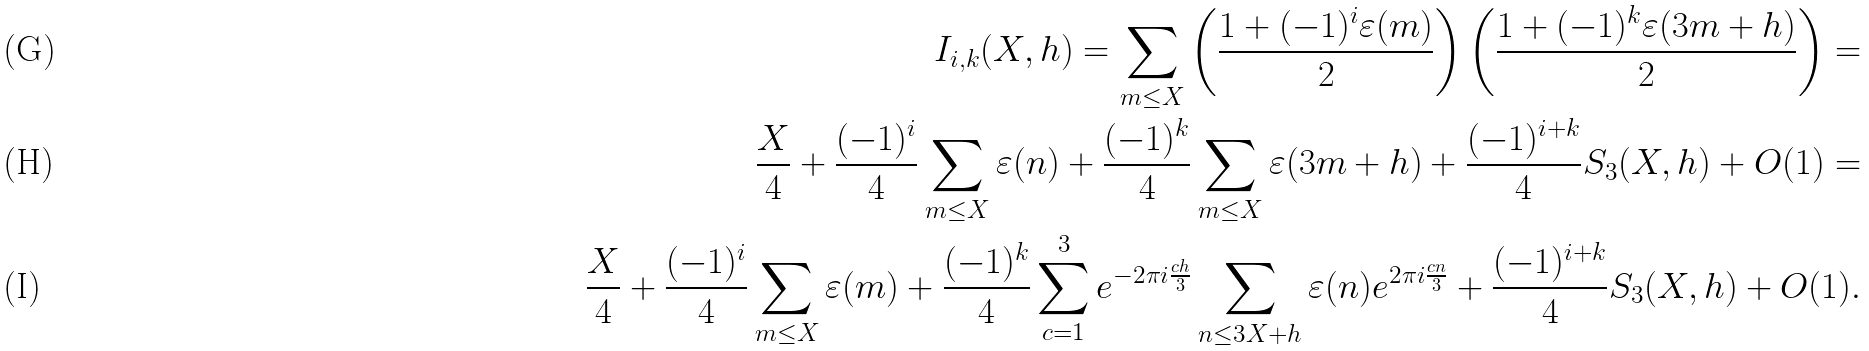Convert formula to latex. <formula><loc_0><loc_0><loc_500><loc_500>I _ { i , k } ( X , h ) = \sum _ { m \leq X } \left ( \frac { 1 + ( - 1 ) ^ { i } \varepsilon ( m ) } { 2 } \right ) \left ( \frac { 1 + ( - 1 ) ^ { k } \varepsilon ( 3 m + h ) } { 2 } \right ) = \\ \frac { X } { 4 } + \frac { ( - 1 ) ^ { i } } { 4 } \sum _ { m \leq X } \varepsilon ( n ) + \frac { ( - 1 ) ^ { k } } { 4 } \sum _ { m \leq X } \varepsilon ( 3 m + h ) + \frac { ( - 1 ) ^ { i + k } } { 4 } S _ { 3 } ( X , h ) + O ( 1 ) = \\ \frac { X } { 4 } + \frac { ( - 1 ) ^ { i } } { 4 } \sum _ { m \leq X } \varepsilon ( m ) + \frac { ( - 1 ) ^ { k } } { 4 } \sum _ { c = 1 } ^ { 3 } e ^ { - 2 \pi i \frac { c h } { 3 } } \sum _ { n \leq 3 X + h } \varepsilon ( n ) e ^ { 2 \pi i \frac { c n } { 3 } } + \frac { ( - 1 ) ^ { i + k } } { 4 } S _ { 3 } ( X , h ) + O ( 1 ) .</formula> 